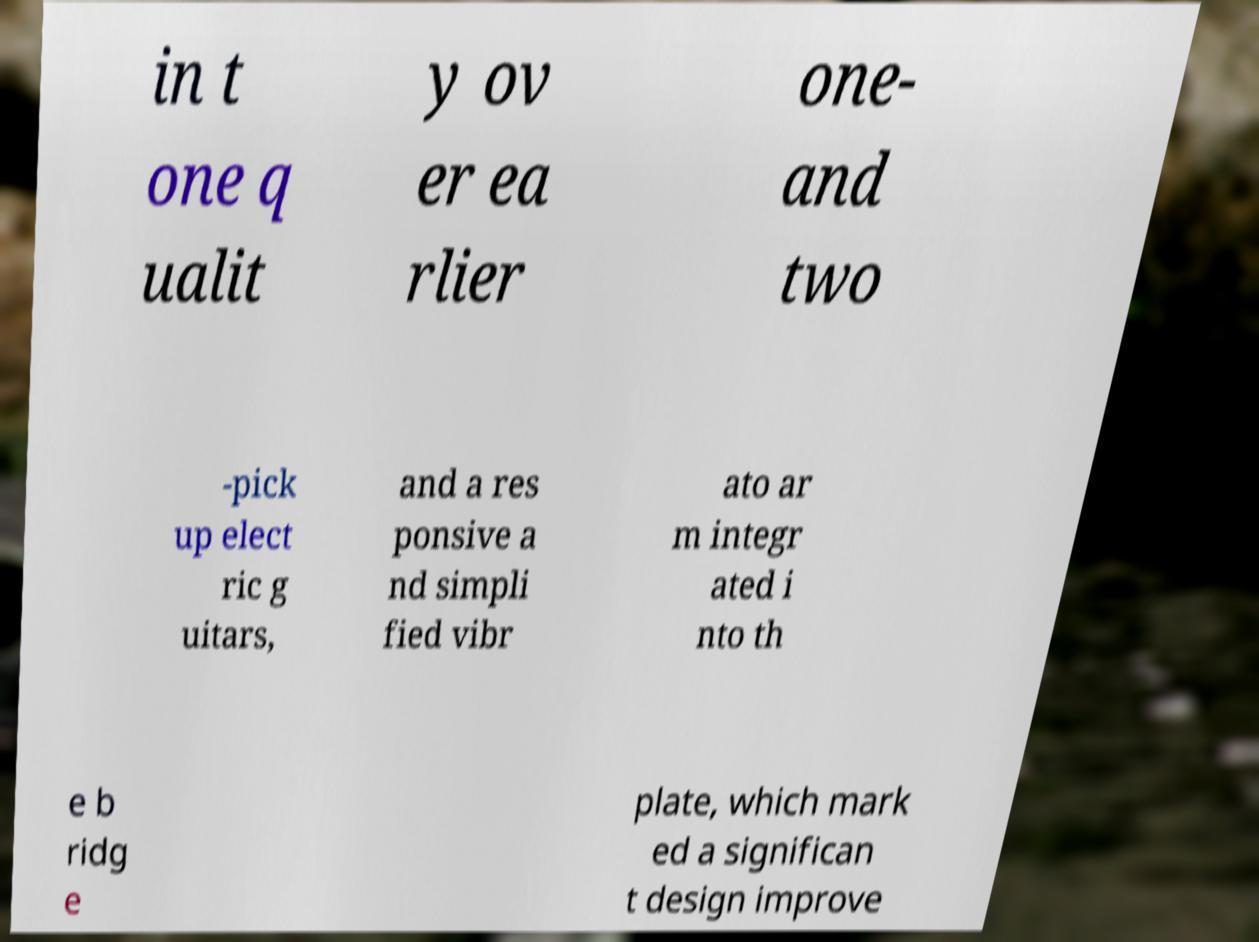Can you accurately transcribe the text from the provided image for me? in t one q ualit y ov er ea rlier one- and two -pick up elect ric g uitars, and a res ponsive a nd simpli fied vibr ato ar m integr ated i nto th e b ridg e plate, which mark ed a significan t design improve 